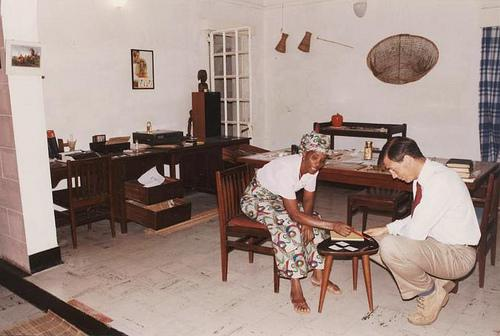Question: where is the woman sitting?
Choices:
A. A couch.
B. A bench.
C. A chair.
D. The floor.
Answer with the letter. Answer: C Question: what color shoes does the man have on?
Choices:
A. Black.
B. Red.
C. Brown.
D. Green.
Answer with the letter. Answer: C Question: who is wearing something on their head?
Choices:
A. The man.
B. The boy.
C. The woman.
D. The girl.
Answer with the letter. Answer: C Question: what pattern is on the curtains?
Choices:
A. Flowers.
B. Polka dots.
C. Stripes.
D. Squares.
Answer with the letter. Answer: C Question: who has bare feet?
Choices:
A. The man.
B. The boy.
C. The woman.
D. The girl.
Answer with the letter. Answer: C 